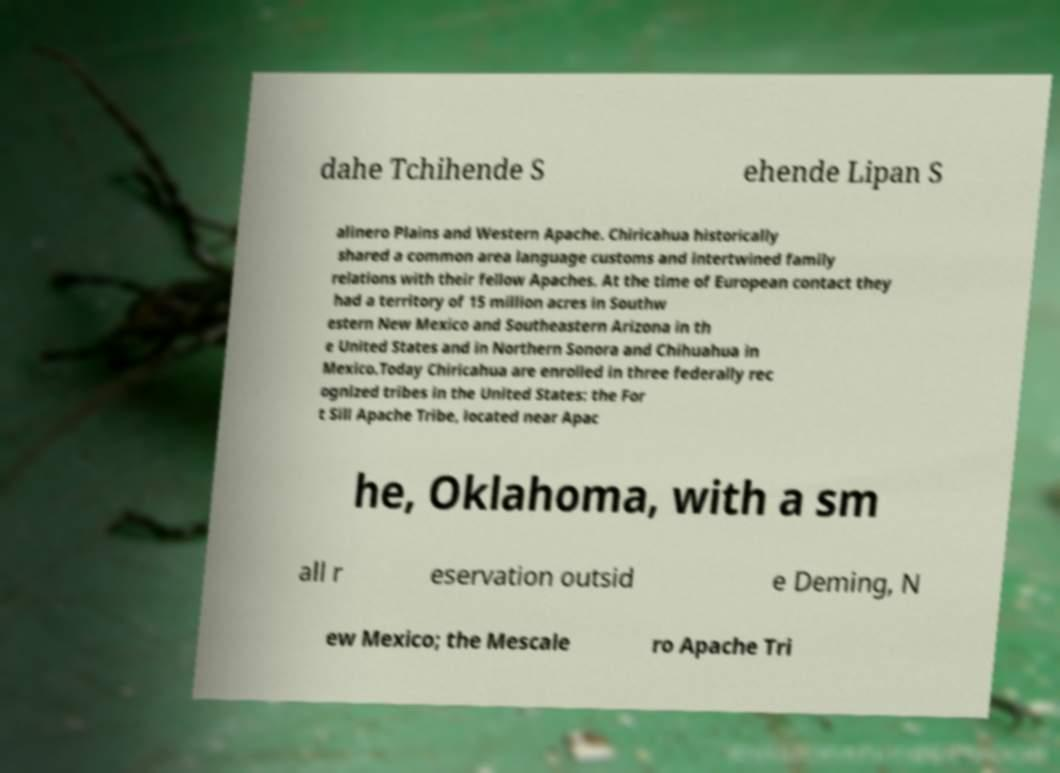I need the written content from this picture converted into text. Can you do that? dahe Tchihende S ehende Lipan S alinero Plains and Western Apache. Chiricahua historically shared a common area language customs and intertwined family relations with their fellow Apaches. At the time of European contact they had a territory of 15 million acres in Southw estern New Mexico and Southeastern Arizona in th e United States and in Northern Sonora and Chihuahua in Mexico.Today Chiricahua are enrolled in three federally rec ognized tribes in the United States: the For t Sill Apache Tribe, located near Apac he, Oklahoma, with a sm all r eservation outsid e Deming, N ew Mexico; the Mescale ro Apache Tri 